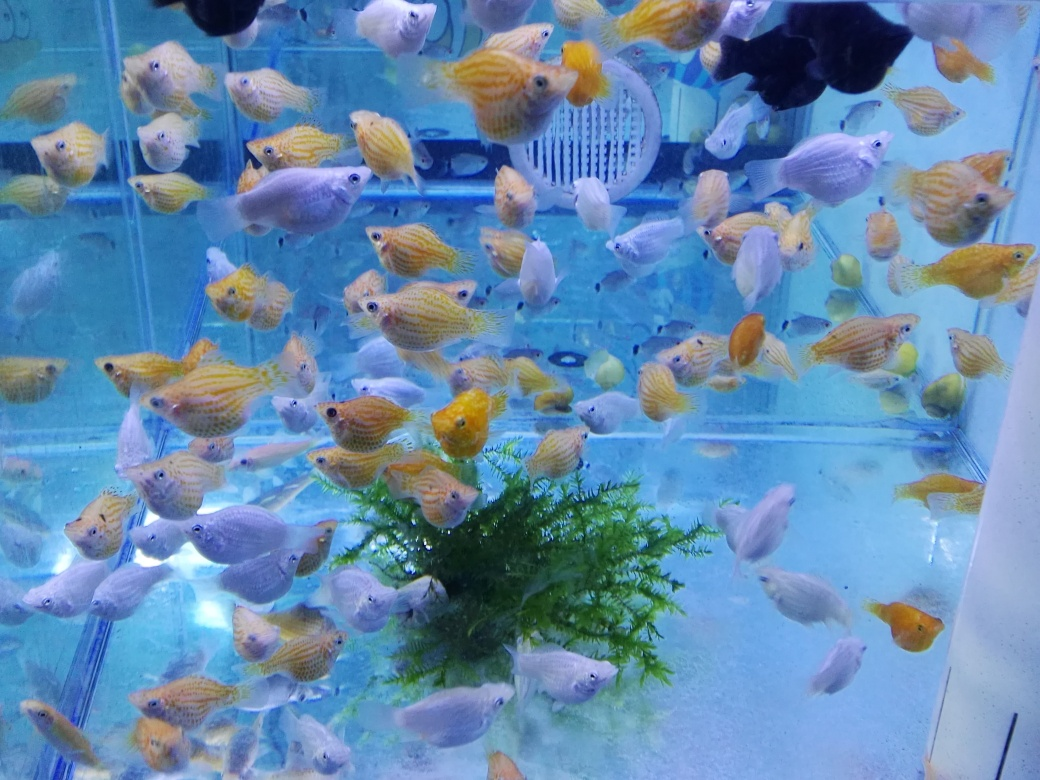Are there any focusing issues in the image? The image appears to be mostly in focus, showcasing a variety of fish with good clarity and detail, although some fish located near the edges might seem a bit less sharp due to lens distortion or movement, which is common in photography of moving subjects such as fish in an aquarium. 